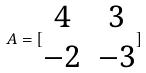Convert formula to latex. <formula><loc_0><loc_0><loc_500><loc_500>A = [ \begin{matrix} 4 & 3 \\ - 2 & - 3 \end{matrix} ]</formula> 